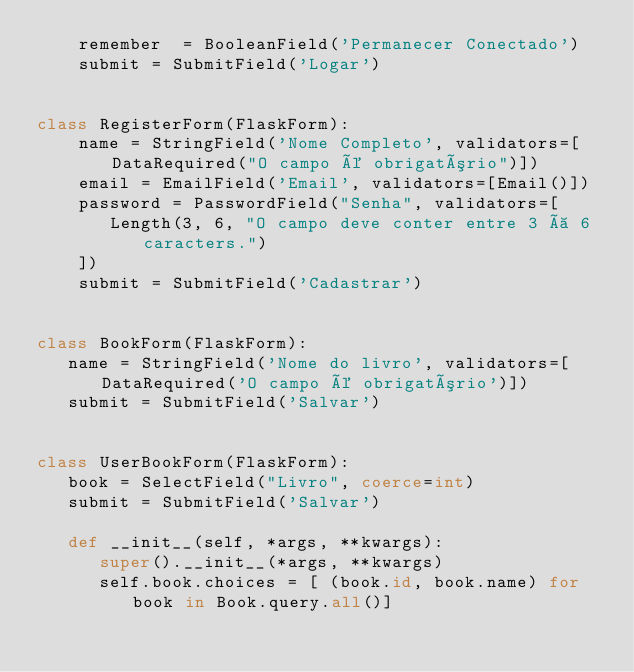Convert code to text. <code><loc_0><loc_0><loc_500><loc_500><_Python_>    remember  = BooleanField('Permanecer Conectado')
    submit = SubmitField('Logar')


class RegisterForm(FlaskForm):
    name = StringField('Nome Completo', validators=[DataRequired("O campo é obrigatório")])
    email = EmailField('Email', validators=[Email()])
    password = PasswordField("Senha", validators=[
       Length(3, 6, "O campo deve conter entre 3 à 6 caracters.")
    ])
    submit = SubmitField('Cadastrar')


class BookForm(FlaskForm):
   name = StringField('Nome do livro', validators=[DataRequired('O campo é obrigatório')])
   submit = SubmitField('Salvar')


class UserBookForm(FlaskForm):
   book = SelectField("Livro", coerce=int)
   submit = SubmitField('Salvar')

   def __init__(self, *args, **kwargs):
      super().__init__(*args, **kwargs)
      self.book.choices = [ (book.id, book.name) for book in Book.query.all()]
</code> 